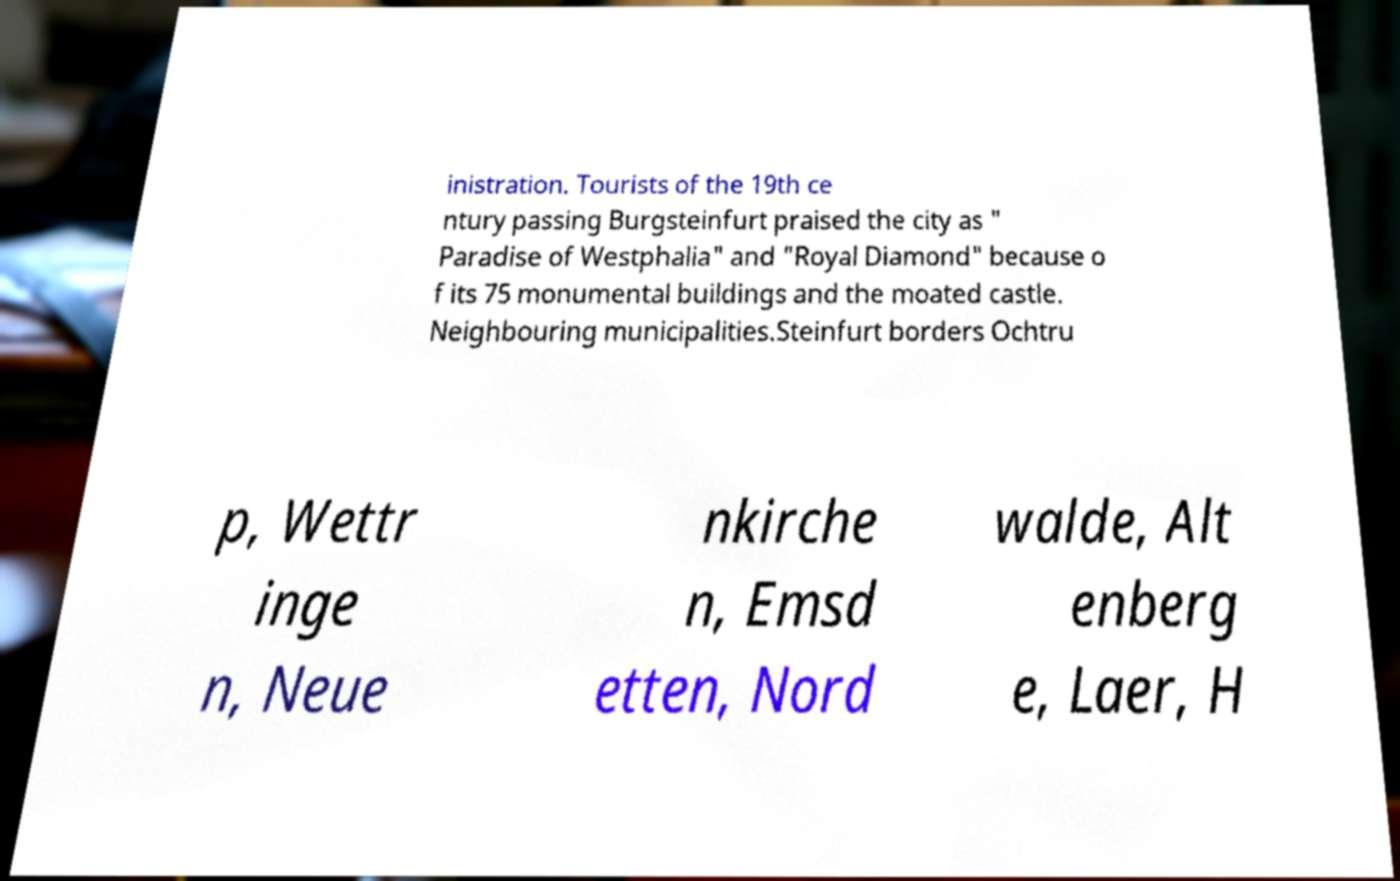Could you extract and type out the text from this image? inistration. Tourists of the 19th ce ntury passing Burgsteinfurt praised the city as " Paradise of Westphalia" and "Royal Diamond" because o f its 75 monumental buildings and the moated castle. Neighbouring municipalities.Steinfurt borders Ochtru p, Wettr inge n, Neue nkirche n, Emsd etten, Nord walde, Alt enberg e, Laer, H 